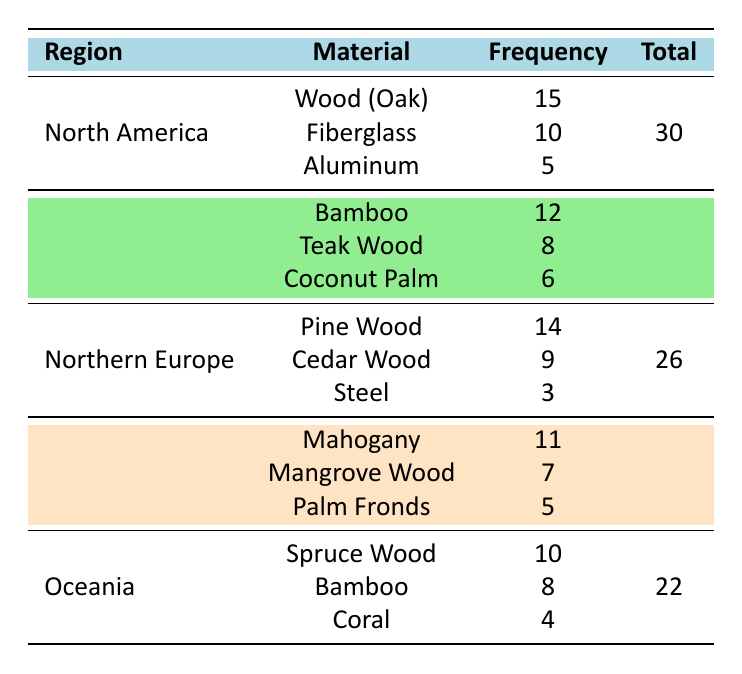What is the most frequently used material in North America? According to the table, the most frequently used material in North America is Wood (Oak) with a frequency of 15.
Answer: Wood (Oak) Which region uses Bamboo as a building material? The table lists Bamboo as a building material in both Southeast Asia and Oceania. Southeast Asia has a frequency of 12, while Oceania has a frequency of 8.
Answer: Southeast Asia and Oceania What is the total frequency of traditional boat-building materials used in Northern Europe? The table shows three materials used in Northern Europe: Pine Wood (14), Cedar Wood (9), and Steel (3). Adding these together, 14 + 9 + 3 gives a total frequency of 26.
Answer: 26 Is Fiberglass more frequently used than Aluminum in North America? In North America, Fiberglass has a frequency of 10, whereas Aluminum has a frequency of 5. Since 10 is greater than 5, the statement is true.
Answer: Yes What is the average frequency of traditional boat-building materials used in West Africa? In West Africa, the materials used are Mahogany (11), Mangrove Wood (7), and Palm Fronds (5). To find the average, we first sum the frequencies: 11 + 7 + 5 = 23. There are 3 materials, so we divide the total (23) by the number of materials (3). Thus, the average frequency is 23/3 ≈ 7.67.
Answer: 7.67 Which material has the lowest frequency in the table? The lowest frequency material is Steel, with a frequency of 3 found in Northern Europe.
Answer: Steel How many more times is Pine Wood used compared to Steel in Northern Europe? Pine Wood has a frequency of 14, while Steel has a frequency of 3. To find the difference: 14 - 3 = 11. This means Pine Wood is used 11 times more than Steel.
Answer: 11 What is the combined frequency of Bamboo used in Southeast Asia and Oceania? Bamboo is used in Southeast Asia with a frequency of 12 and in Oceania with a frequency of 8. Adding these gives 12 + 8 = 20.
Answer: 20 Does North America have a higher total frequency than Oceania for traditional boat-building materials? North America has a total frequency of 30, while Oceania has a total frequency of 22. Since 30 is greater than 22, the answer is yes.
Answer: Yes 